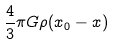Convert formula to latex. <formula><loc_0><loc_0><loc_500><loc_500>\frac { 4 } { 3 } \pi G \rho ( x _ { 0 } - x )</formula> 